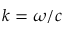Convert formula to latex. <formula><loc_0><loc_0><loc_500><loc_500>k = \omega / c</formula> 